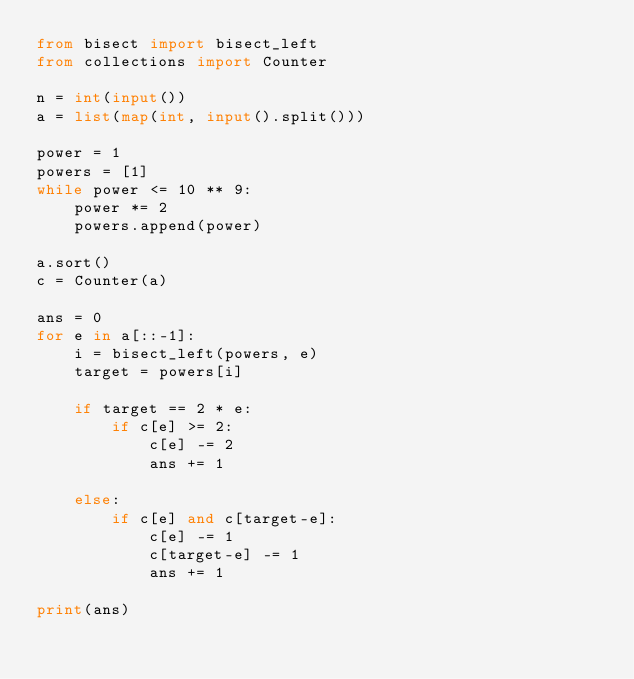<code> <loc_0><loc_0><loc_500><loc_500><_Python_>from bisect import bisect_left
from collections import Counter

n = int(input())
a = list(map(int, input().split()))

power = 1
powers = [1]
while power <= 10 ** 9:
    power *= 2
    powers.append(power)

a.sort()
c = Counter(a)

ans = 0
for e in a[::-1]:
    i = bisect_left(powers, e)
    target = powers[i]

    if target == 2 * e:
        if c[e] >= 2:
            c[e] -= 2
            ans += 1

    else:
        if c[e] and c[target-e]:
            c[e] -= 1
            c[target-e] -= 1
            ans += 1

print(ans)
</code> 